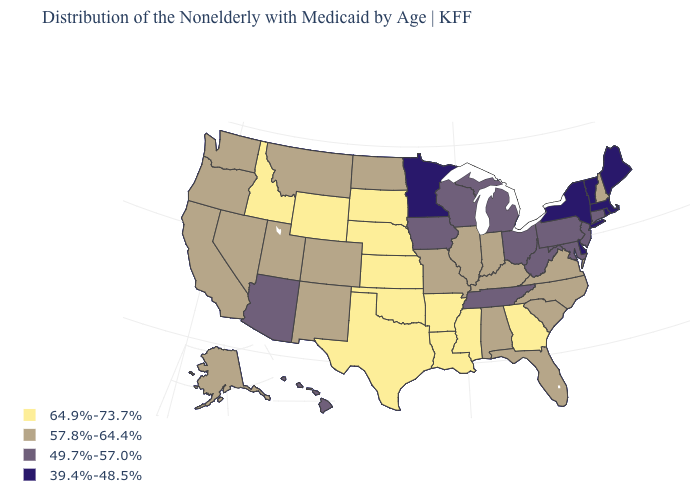What is the value of Maryland?
Be succinct. 49.7%-57.0%. How many symbols are there in the legend?
Give a very brief answer. 4. What is the value of Georgia?
Concise answer only. 64.9%-73.7%. What is the value of New Hampshire?
Quick response, please. 57.8%-64.4%. What is the value of New York?
Answer briefly. 39.4%-48.5%. Name the states that have a value in the range 39.4%-48.5%?
Quick response, please. Delaware, Maine, Massachusetts, Minnesota, New York, Rhode Island, Vermont. Among the states that border New Mexico , does Texas have the highest value?
Write a very short answer. Yes. What is the highest value in the West ?
Write a very short answer. 64.9%-73.7%. Which states have the lowest value in the Northeast?
Answer briefly. Maine, Massachusetts, New York, Rhode Island, Vermont. What is the value of Alabama?
Give a very brief answer. 57.8%-64.4%. Does Indiana have the highest value in the USA?
Quick response, please. No. Does Texas have the highest value in the South?
Be succinct. Yes. What is the value of Georgia?
Be succinct. 64.9%-73.7%. Does Illinois have the highest value in the MidWest?
Short answer required. No. Does Vermont have a lower value than North Carolina?
Short answer required. Yes. 